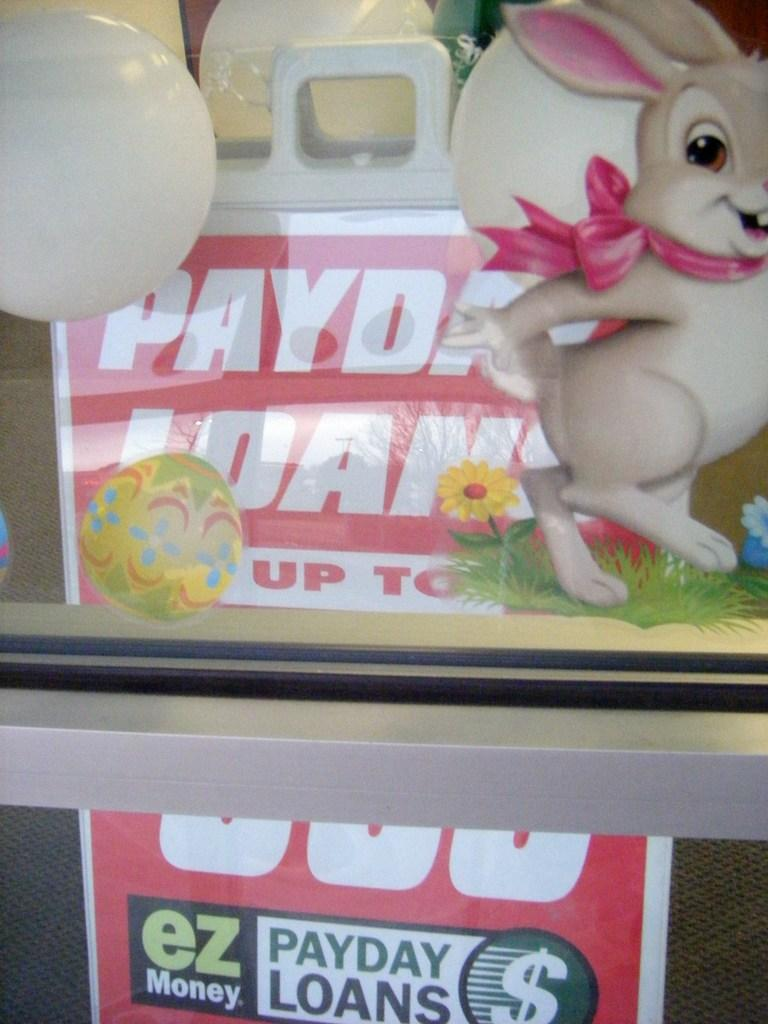<image>
Give a short and clear explanation of the subsequent image. A sign advertising PayDay Loans EZ Money on it. 